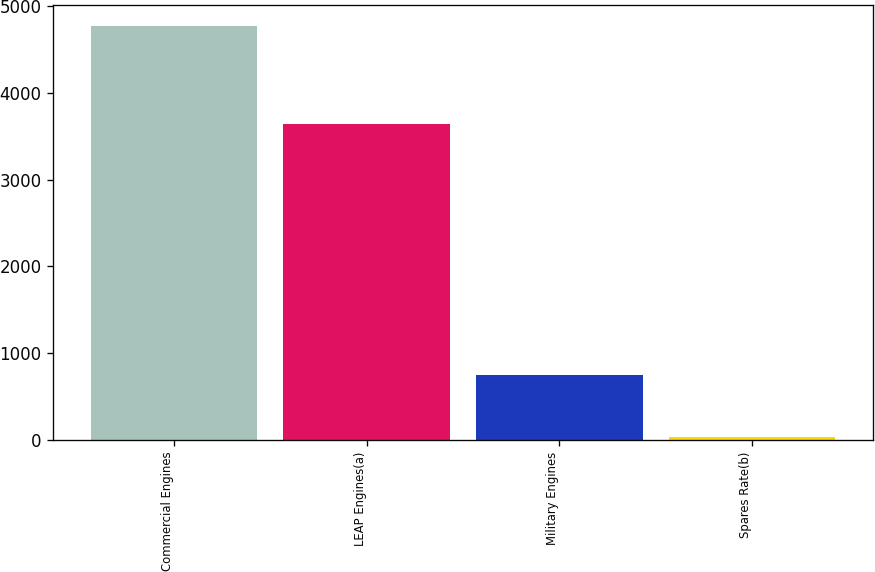<chart> <loc_0><loc_0><loc_500><loc_500><bar_chart><fcel>Commercial Engines<fcel>LEAP Engines(a)<fcel>Military Engines<fcel>Spares Rate(b)<nl><fcel>4772<fcel>3637<fcel>751<fcel>27.5<nl></chart> 